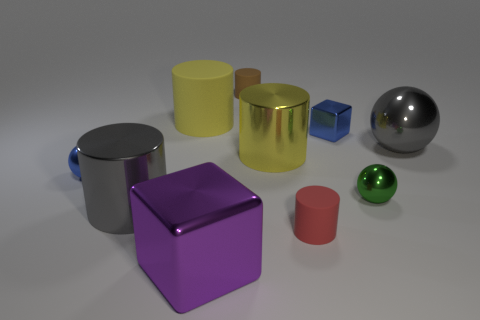Are there any metal spheres of the same color as the small metallic block?
Provide a short and direct response. Yes. Do the big rubber object and the metallic cylinder that is right of the yellow matte cylinder have the same color?
Make the answer very short. Yes. There is a big gray metal object behind the green metal sphere; how many large things are behind it?
Offer a terse response. 1. Are there any big spheres in front of the brown cylinder?
Ensure brevity in your answer.  Yes. There is a yellow object in front of the gray shiny object on the right side of the tiny cube; what shape is it?
Provide a short and direct response. Cylinder. Is the number of red objects that are right of the large shiny sphere less than the number of metallic cubes to the left of the small brown rubber object?
Your answer should be compact. Yes. The other small metallic thing that is the same shape as the purple thing is what color?
Give a very brief answer. Blue. What number of small objects are both right of the small blue ball and in front of the big yellow rubber object?
Offer a terse response. 3. Is the number of big gray objects that are right of the brown matte cylinder greater than the number of big rubber cylinders right of the large yellow shiny thing?
Your response must be concise. Yes. The yellow shiny cylinder has what size?
Give a very brief answer. Large. 